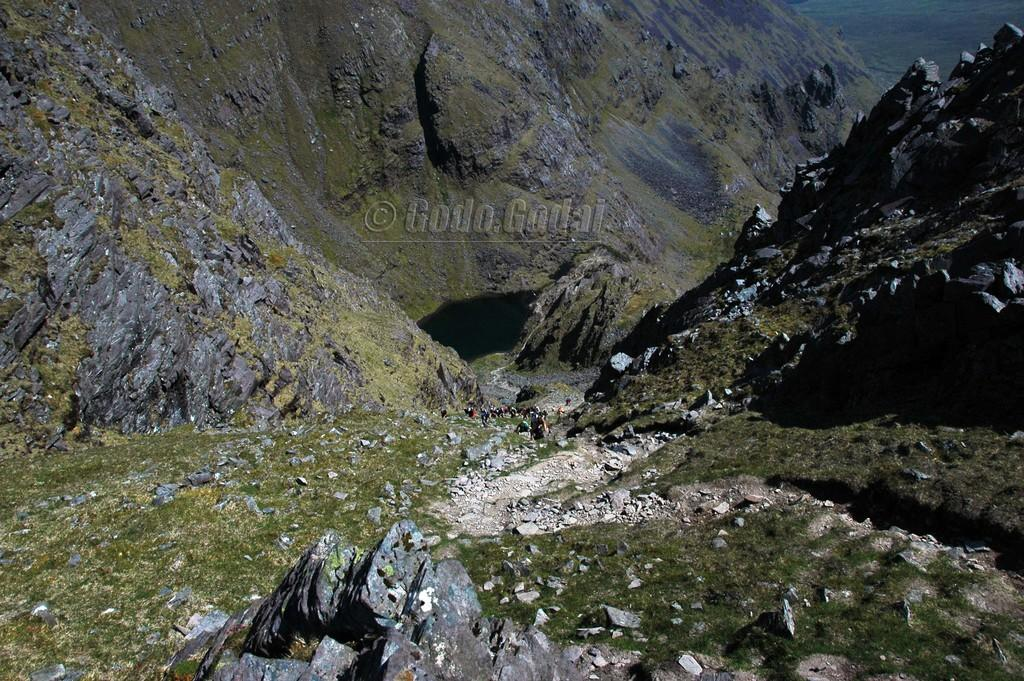What type of terrain is visible in the image? There are hills in the image. What can be found on the ground in the image? There are stones and grass visible in the image. Are there any living beings in the image? Yes, there are people in the image. Is there any indication of digital manipulation or ownership in the image? Yes, there is a watermark in the image. What type of mask is being worn by the people in the image? There are no masks visible in the image; the people are not wearing any masks. What can of can is being used by the people in the image? There are no cans visible in the image; the people are not using any cans. 